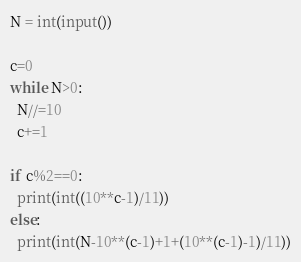<code> <loc_0><loc_0><loc_500><loc_500><_Python_>N = int(input())

c=0
while N>0:
  N//=10
  c+=1

if c%2==0:
  print(int((10**c-1)/11))
else: 
  print(int(N-10**(c-1)+1+(10**(c-1)-1)/11))</code> 